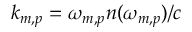<formula> <loc_0><loc_0><loc_500><loc_500>k _ { m , p } = \omega _ { m , p } n ( \omega _ { m , p } ) / c</formula> 